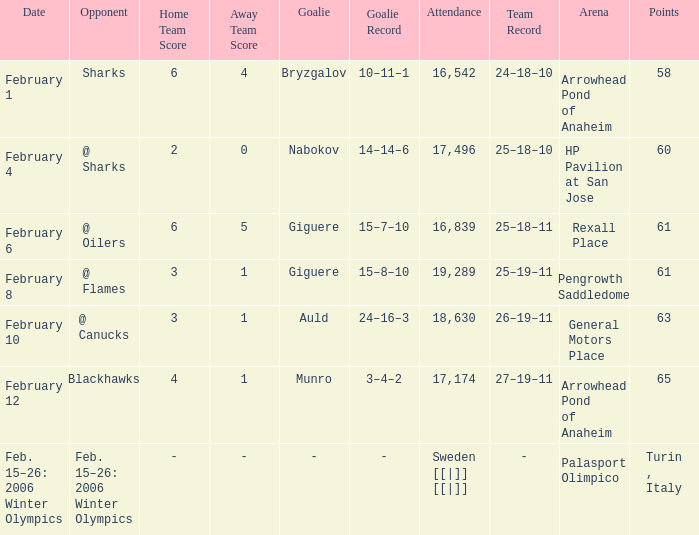What is the score when the points were 3-1, and the record was 25-19-11? 61.0. 